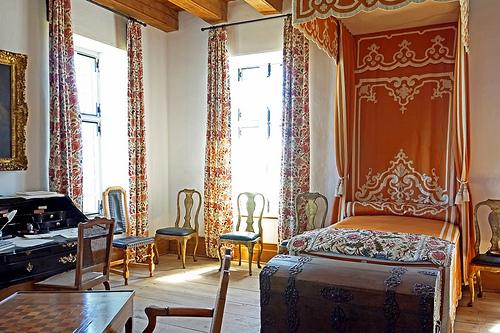Provide a brief description of the atmosphere created by the sunlight in the image. The sunlight shining through the window creates a warm and inviting atmosphere in the room. Using adjectives, describe the picture frame hanging on the wall. The picture frame is gold, ornate, and rectangular, hanging prominently on the wall. Write a general description of the scene in the image. A room with a tall canopy bed, wooden furniture, large window with floral drapes, chess board on table, and sun shining through the window. Explain the position of the chess board and how it can be interacted with. The chess board is on a table near a wooden chair, allowing someone to sit down and play chess. Describe one key aspect of the ceiling in the image. The ceiling has wooden beams, adding a rustic charm to the space. Describe the furniture arrangement in the image. A tall canopy bed is near the draped window, a wooden chair with a chess board on a table is across, and a desk with a paper on it is by the window. Mention one interesting detail about the bed and one interesting detail about the window. The bed has an orange and white canopy, while the window has floral drapes on the side. List down five prominent objects that you see in the image. Canopy bed, large window, wooden chair, chess board, and gold framed picture on the wall. Write a sentence describing the floor in the image. The floor is made of light-colored wood, providing a bright and spacious feel to the room. State the dominant color scheme of the items in the image. The room has a predominantly brown and blue color scheme with elements of gold, white, and orange. 